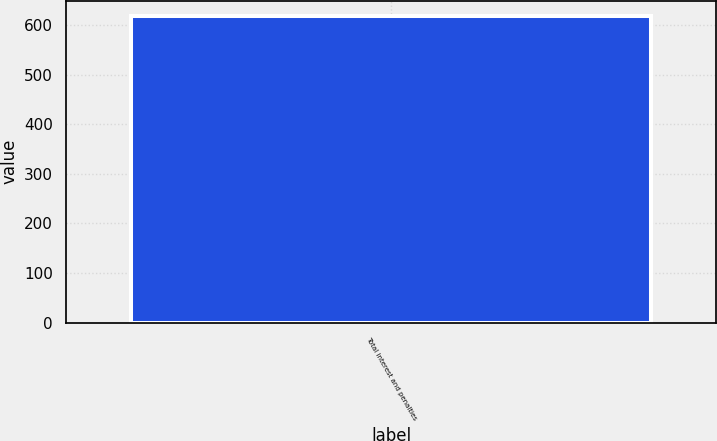Convert chart. <chart><loc_0><loc_0><loc_500><loc_500><bar_chart><fcel>Total interest and penalties<nl><fcel>618<nl></chart> 